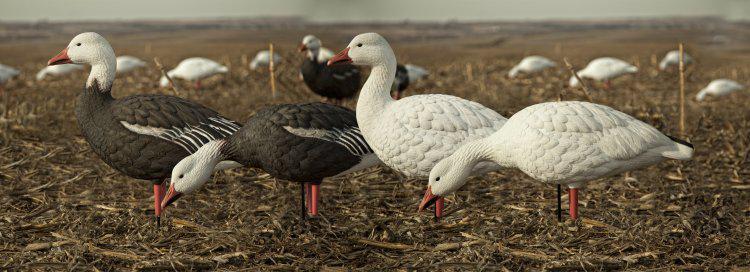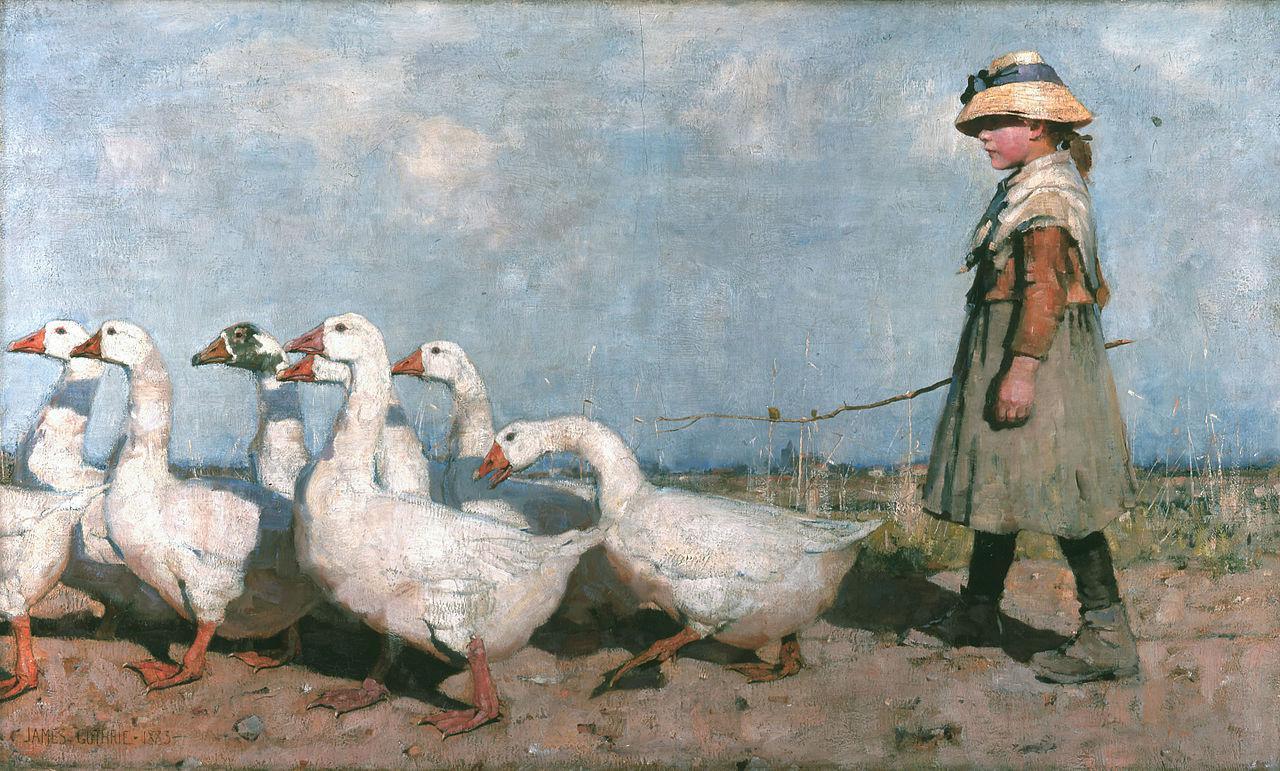The first image is the image on the left, the second image is the image on the right. For the images displayed, is the sentence "An image shows a girl in a head covering standing behind a flock of white birds and holding a stick." factually correct? Answer yes or no. Yes. The first image is the image on the left, the second image is the image on the right. For the images shown, is this caption "At least one person is walking with the birds in one of the images." true? Answer yes or no. Yes. 